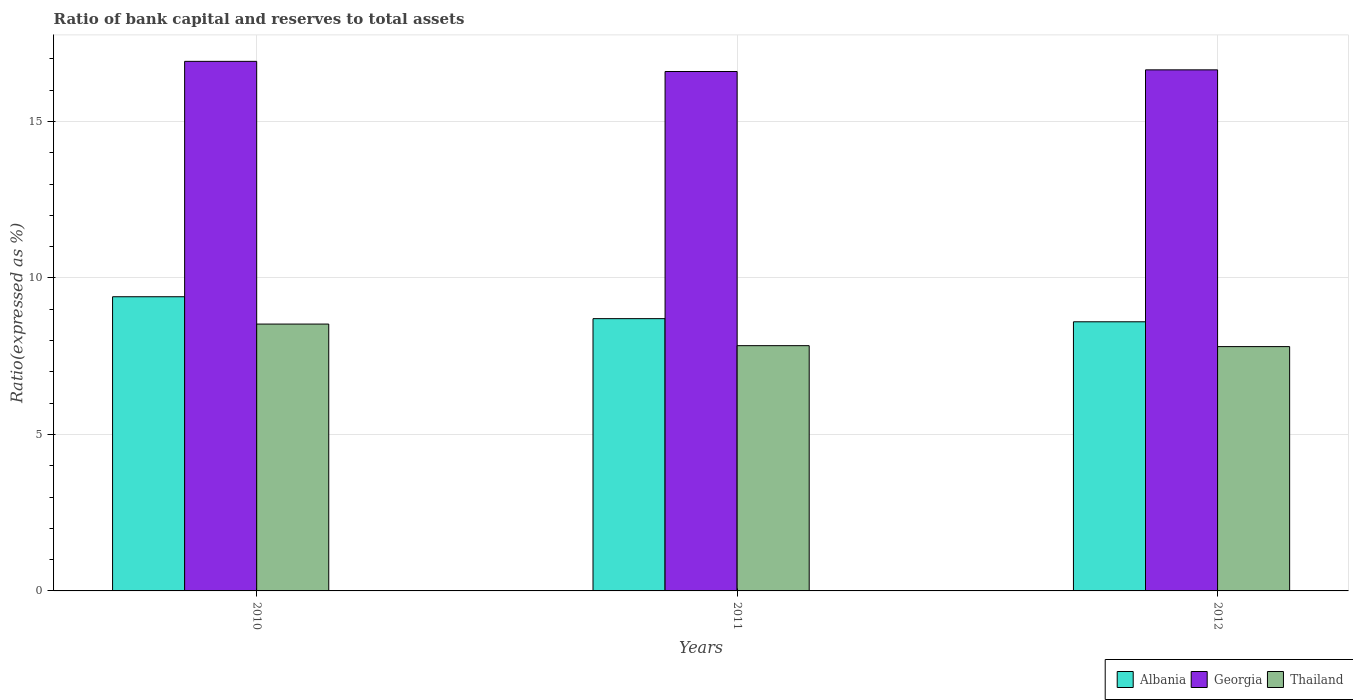Are the number of bars per tick equal to the number of legend labels?
Provide a short and direct response. Yes. How many bars are there on the 3rd tick from the left?
Give a very brief answer. 3. What is the label of the 1st group of bars from the left?
Your answer should be very brief. 2010. Across all years, what is the maximum ratio of bank capital and reserves to total assets in Thailand?
Provide a short and direct response. 8.53. Across all years, what is the minimum ratio of bank capital and reserves to total assets in Albania?
Ensure brevity in your answer.  8.6. What is the total ratio of bank capital and reserves to total assets in Thailand in the graph?
Make the answer very short. 24.17. What is the difference between the ratio of bank capital and reserves to total assets in Albania in 2010 and that in 2012?
Your answer should be compact. 0.8. What is the difference between the ratio of bank capital and reserves to total assets in Thailand in 2010 and the ratio of bank capital and reserves to total assets in Albania in 2012?
Ensure brevity in your answer.  -0.07. In the year 2012, what is the difference between the ratio of bank capital and reserves to total assets in Albania and ratio of bank capital and reserves to total assets in Georgia?
Ensure brevity in your answer.  -8.05. In how many years, is the ratio of bank capital and reserves to total assets in Albania greater than 3 %?
Make the answer very short. 3. What is the ratio of the ratio of bank capital and reserves to total assets in Georgia in 2010 to that in 2012?
Provide a short and direct response. 1.02. Is the ratio of bank capital and reserves to total assets in Thailand in 2010 less than that in 2012?
Your response must be concise. No. What is the difference between the highest and the second highest ratio of bank capital and reserves to total assets in Georgia?
Your answer should be compact. 0.27. What is the difference between the highest and the lowest ratio of bank capital and reserves to total assets in Albania?
Your answer should be compact. 0.8. Is the sum of the ratio of bank capital and reserves to total assets in Thailand in 2010 and 2012 greater than the maximum ratio of bank capital and reserves to total assets in Georgia across all years?
Offer a very short reply. No. What does the 3rd bar from the left in 2012 represents?
Your answer should be very brief. Thailand. What does the 1st bar from the right in 2011 represents?
Your answer should be very brief. Thailand. Is it the case that in every year, the sum of the ratio of bank capital and reserves to total assets in Georgia and ratio of bank capital and reserves to total assets in Albania is greater than the ratio of bank capital and reserves to total assets in Thailand?
Your answer should be very brief. Yes. How many bars are there?
Your response must be concise. 9. Are all the bars in the graph horizontal?
Provide a short and direct response. No. How are the legend labels stacked?
Offer a very short reply. Horizontal. What is the title of the graph?
Keep it short and to the point. Ratio of bank capital and reserves to total assets. Does "Mali" appear as one of the legend labels in the graph?
Ensure brevity in your answer.  No. What is the label or title of the Y-axis?
Your answer should be very brief. Ratio(expressed as %). What is the Ratio(expressed as %) of Albania in 2010?
Your answer should be very brief. 9.4. What is the Ratio(expressed as %) in Georgia in 2010?
Keep it short and to the point. 16.92. What is the Ratio(expressed as %) in Thailand in 2010?
Make the answer very short. 8.53. What is the Ratio(expressed as %) in Albania in 2011?
Offer a very short reply. 8.7. What is the Ratio(expressed as %) in Georgia in 2011?
Offer a terse response. 16.6. What is the Ratio(expressed as %) of Thailand in 2011?
Provide a short and direct response. 7.84. What is the Ratio(expressed as %) of Albania in 2012?
Make the answer very short. 8.6. What is the Ratio(expressed as %) of Georgia in 2012?
Keep it short and to the point. 16.65. What is the Ratio(expressed as %) in Thailand in 2012?
Give a very brief answer. 7.81. Across all years, what is the maximum Ratio(expressed as %) of Georgia?
Give a very brief answer. 16.92. Across all years, what is the maximum Ratio(expressed as %) of Thailand?
Provide a succinct answer. 8.53. Across all years, what is the minimum Ratio(expressed as %) of Albania?
Give a very brief answer. 8.6. Across all years, what is the minimum Ratio(expressed as %) of Georgia?
Make the answer very short. 16.6. Across all years, what is the minimum Ratio(expressed as %) in Thailand?
Keep it short and to the point. 7.81. What is the total Ratio(expressed as %) in Albania in the graph?
Your response must be concise. 26.7. What is the total Ratio(expressed as %) of Georgia in the graph?
Provide a succinct answer. 50.17. What is the total Ratio(expressed as %) in Thailand in the graph?
Your answer should be compact. 24.17. What is the difference between the Ratio(expressed as %) of Georgia in 2010 and that in 2011?
Provide a short and direct response. 0.32. What is the difference between the Ratio(expressed as %) in Thailand in 2010 and that in 2011?
Give a very brief answer. 0.69. What is the difference between the Ratio(expressed as %) of Albania in 2010 and that in 2012?
Your answer should be very brief. 0.8. What is the difference between the Ratio(expressed as %) in Georgia in 2010 and that in 2012?
Ensure brevity in your answer.  0.27. What is the difference between the Ratio(expressed as %) of Thailand in 2010 and that in 2012?
Your answer should be compact. 0.72. What is the difference between the Ratio(expressed as %) of Albania in 2011 and that in 2012?
Ensure brevity in your answer.  0.1. What is the difference between the Ratio(expressed as %) in Georgia in 2011 and that in 2012?
Make the answer very short. -0.05. What is the difference between the Ratio(expressed as %) in Thailand in 2011 and that in 2012?
Offer a terse response. 0.03. What is the difference between the Ratio(expressed as %) in Albania in 2010 and the Ratio(expressed as %) in Georgia in 2011?
Your answer should be very brief. -7.2. What is the difference between the Ratio(expressed as %) of Albania in 2010 and the Ratio(expressed as %) of Thailand in 2011?
Ensure brevity in your answer.  1.56. What is the difference between the Ratio(expressed as %) of Georgia in 2010 and the Ratio(expressed as %) of Thailand in 2011?
Give a very brief answer. 9.09. What is the difference between the Ratio(expressed as %) of Albania in 2010 and the Ratio(expressed as %) of Georgia in 2012?
Offer a very short reply. -7.25. What is the difference between the Ratio(expressed as %) in Albania in 2010 and the Ratio(expressed as %) in Thailand in 2012?
Provide a succinct answer. 1.59. What is the difference between the Ratio(expressed as %) of Georgia in 2010 and the Ratio(expressed as %) of Thailand in 2012?
Your response must be concise. 9.12. What is the difference between the Ratio(expressed as %) in Albania in 2011 and the Ratio(expressed as %) in Georgia in 2012?
Your answer should be very brief. -7.95. What is the difference between the Ratio(expressed as %) in Albania in 2011 and the Ratio(expressed as %) in Thailand in 2012?
Provide a short and direct response. 0.89. What is the difference between the Ratio(expressed as %) in Georgia in 2011 and the Ratio(expressed as %) in Thailand in 2012?
Provide a short and direct response. 8.79. What is the average Ratio(expressed as %) in Georgia per year?
Offer a terse response. 16.72. What is the average Ratio(expressed as %) in Thailand per year?
Your answer should be very brief. 8.06. In the year 2010, what is the difference between the Ratio(expressed as %) of Albania and Ratio(expressed as %) of Georgia?
Provide a short and direct response. -7.52. In the year 2010, what is the difference between the Ratio(expressed as %) in Albania and Ratio(expressed as %) in Thailand?
Provide a succinct answer. 0.87. In the year 2010, what is the difference between the Ratio(expressed as %) in Georgia and Ratio(expressed as %) in Thailand?
Provide a succinct answer. 8.39. In the year 2011, what is the difference between the Ratio(expressed as %) of Albania and Ratio(expressed as %) of Georgia?
Your answer should be very brief. -7.9. In the year 2011, what is the difference between the Ratio(expressed as %) in Albania and Ratio(expressed as %) in Thailand?
Keep it short and to the point. 0.86. In the year 2011, what is the difference between the Ratio(expressed as %) of Georgia and Ratio(expressed as %) of Thailand?
Your response must be concise. 8.76. In the year 2012, what is the difference between the Ratio(expressed as %) in Albania and Ratio(expressed as %) in Georgia?
Keep it short and to the point. -8.05. In the year 2012, what is the difference between the Ratio(expressed as %) of Albania and Ratio(expressed as %) of Thailand?
Offer a very short reply. 0.79. In the year 2012, what is the difference between the Ratio(expressed as %) of Georgia and Ratio(expressed as %) of Thailand?
Make the answer very short. 8.84. What is the ratio of the Ratio(expressed as %) of Albania in 2010 to that in 2011?
Your response must be concise. 1.08. What is the ratio of the Ratio(expressed as %) in Georgia in 2010 to that in 2011?
Make the answer very short. 1.02. What is the ratio of the Ratio(expressed as %) of Thailand in 2010 to that in 2011?
Make the answer very short. 1.09. What is the ratio of the Ratio(expressed as %) of Albania in 2010 to that in 2012?
Provide a succinct answer. 1.09. What is the ratio of the Ratio(expressed as %) of Georgia in 2010 to that in 2012?
Ensure brevity in your answer.  1.02. What is the ratio of the Ratio(expressed as %) in Thailand in 2010 to that in 2012?
Offer a terse response. 1.09. What is the ratio of the Ratio(expressed as %) in Albania in 2011 to that in 2012?
Your answer should be very brief. 1.01. What is the ratio of the Ratio(expressed as %) of Georgia in 2011 to that in 2012?
Make the answer very short. 1. What is the difference between the highest and the second highest Ratio(expressed as %) in Albania?
Offer a terse response. 0.7. What is the difference between the highest and the second highest Ratio(expressed as %) in Georgia?
Provide a short and direct response. 0.27. What is the difference between the highest and the second highest Ratio(expressed as %) of Thailand?
Your answer should be very brief. 0.69. What is the difference between the highest and the lowest Ratio(expressed as %) of Georgia?
Provide a short and direct response. 0.32. What is the difference between the highest and the lowest Ratio(expressed as %) in Thailand?
Provide a succinct answer. 0.72. 